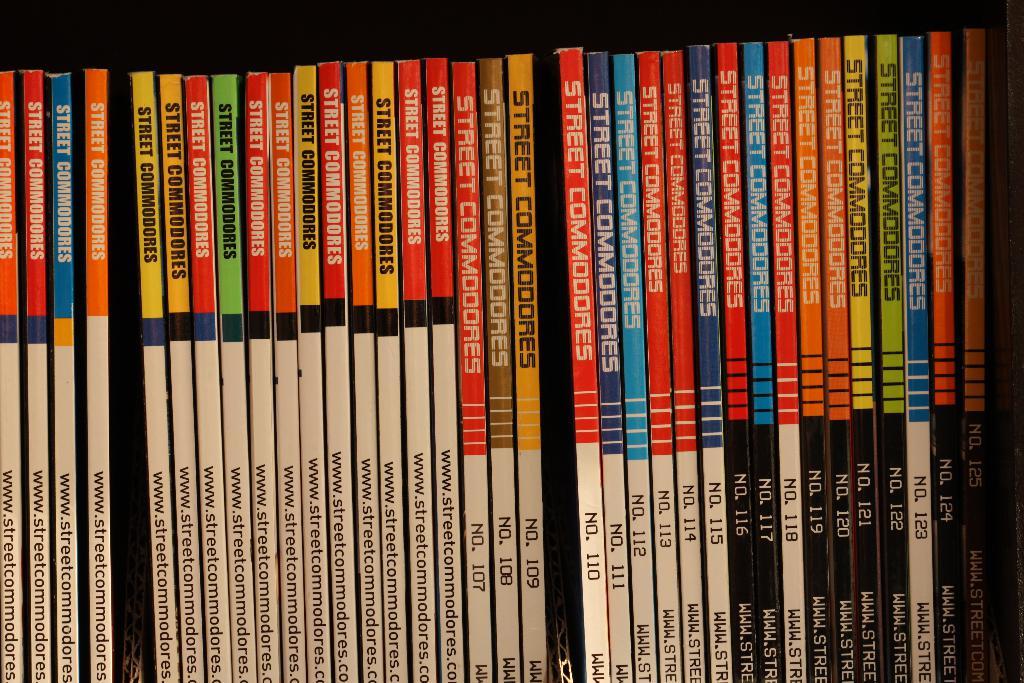What is the issue of the magazine after the small gap?
Make the answer very short. Unanswerable. 